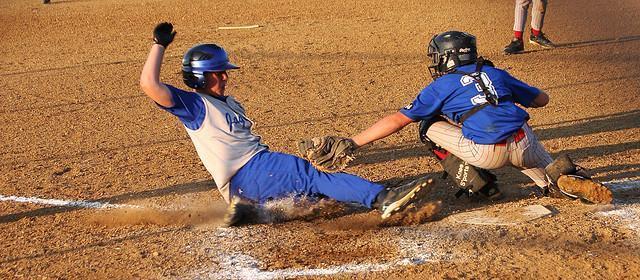How many people can be seen?
Give a very brief answer. 2. 